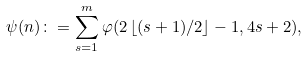<formula> <loc_0><loc_0><loc_500><loc_500>\psi ( n ) \colon = \sum _ { s = 1 } ^ { m } \varphi ( 2 \left \lfloor ( s + 1 ) / 2 \right \rfloor - 1 , 4 s + 2 ) ,</formula> 